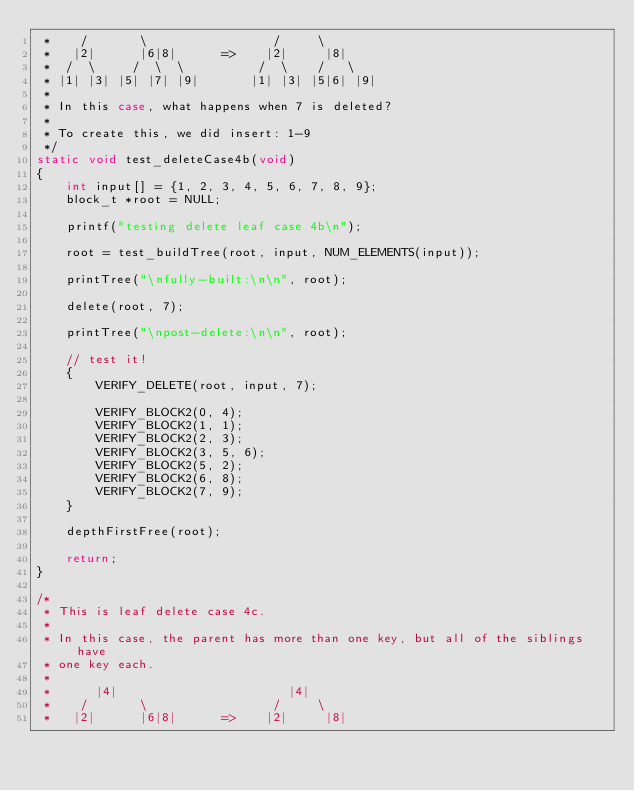<code> <loc_0><loc_0><loc_500><loc_500><_C_> *    /       \                 /     \
 *   |2|      |6|8|      =>    |2|     |8|
 *  /  \     /  \  \          /  \    /   \
 * |1| |3| |5| |7| |9|       |1| |3| |5|6| |9|
 *
 * In this case, what happens when 7 is deleted?
 *
 * To create this, we did insert: 1-9
 */
static void test_deleteCase4b(void)
{
    int input[] = {1, 2, 3, 4, 5, 6, 7, 8, 9};
    block_t *root = NULL;

    printf("testing delete leaf case 4b\n");

    root = test_buildTree(root, input, NUM_ELEMENTS(input));

    printTree("\nfully-built:\n\n", root);

    delete(root, 7);

    printTree("\npost-delete:\n\n", root);

    // test it!
    {
        VERIFY_DELETE(root, input, 7);

        VERIFY_BLOCK2(0, 4);
        VERIFY_BLOCK2(1, 1);
        VERIFY_BLOCK2(2, 3);
        VERIFY_BLOCK2(3, 5, 6);
        VERIFY_BLOCK2(5, 2);
        VERIFY_BLOCK2(6, 8);
        VERIFY_BLOCK2(7, 9);
    }

    depthFirstFree(root);

    return;
}

/*
 * This is leaf delete case 4c.
 *
 * In this case, the parent has more than one key, but all of the siblings have
 * one key each.
 *
 *      |4|                       |4|
 *    /       \                 /     \
 *   |2|      |6|8|      =>    |2|     |8|</code> 